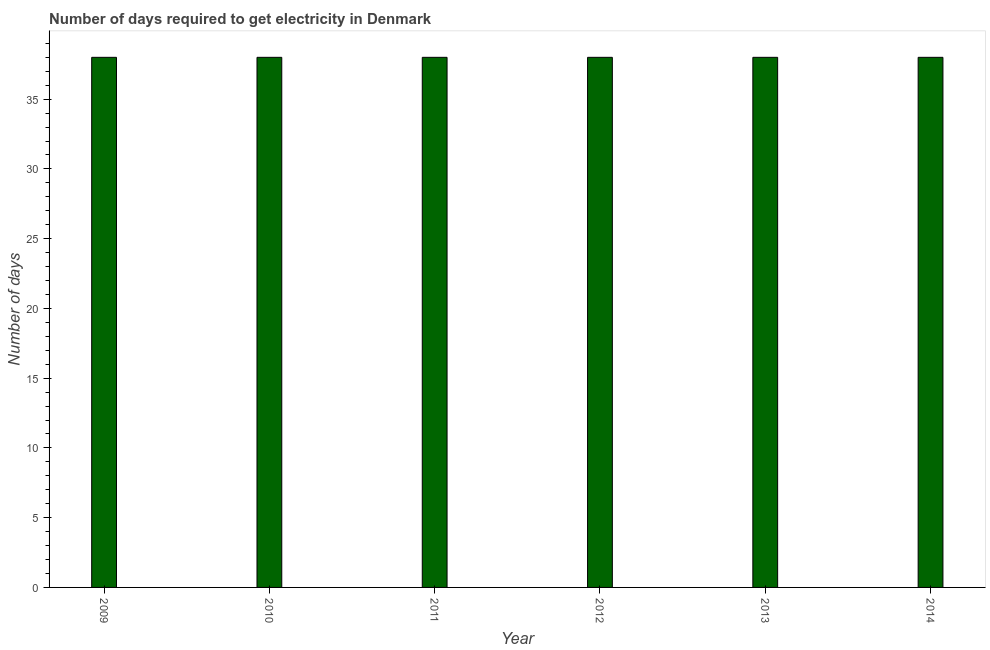Does the graph contain any zero values?
Your answer should be very brief. No. Does the graph contain grids?
Provide a succinct answer. No. What is the title of the graph?
Make the answer very short. Number of days required to get electricity in Denmark. What is the label or title of the X-axis?
Provide a succinct answer. Year. What is the label or title of the Y-axis?
Make the answer very short. Number of days. In which year was the time to get electricity maximum?
Make the answer very short. 2009. What is the sum of the time to get electricity?
Provide a succinct answer. 228. What is the difference between the time to get electricity in 2013 and 2014?
Your answer should be very brief. 0. What is the average time to get electricity per year?
Offer a terse response. 38. What is the median time to get electricity?
Give a very brief answer. 38. In how many years, is the time to get electricity greater than 9 ?
Your answer should be very brief. 6. Is the time to get electricity in 2010 less than that in 2012?
Make the answer very short. No. Is the sum of the time to get electricity in 2010 and 2011 greater than the maximum time to get electricity across all years?
Provide a short and direct response. Yes. Are all the bars in the graph horizontal?
Keep it short and to the point. No. How many years are there in the graph?
Your answer should be very brief. 6. What is the difference between two consecutive major ticks on the Y-axis?
Your answer should be very brief. 5. What is the Number of days of 2010?
Make the answer very short. 38. What is the Number of days in 2011?
Provide a succinct answer. 38. What is the Number of days of 2014?
Keep it short and to the point. 38. What is the difference between the Number of days in 2009 and 2010?
Your response must be concise. 0. What is the difference between the Number of days in 2009 and 2011?
Offer a very short reply. 0. What is the difference between the Number of days in 2009 and 2013?
Ensure brevity in your answer.  0. What is the difference between the Number of days in 2010 and 2011?
Offer a very short reply. 0. What is the difference between the Number of days in 2010 and 2013?
Offer a terse response. 0. What is the difference between the Number of days in 2011 and 2013?
Your response must be concise. 0. What is the difference between the Number of days in 2011 and 2014?
Offer a terse response. 0. What is the ratio of the Number of days in 2009 to that in 2012?
Make the answer very short. 1. What is the ratio of the Number of days in 2009 to that in 2013?
Provide a succinct answer. 1. What is the ratio of the Number of days in 2010 to that in 2012?
Provide a succinct answer. 1. What is the ratio of the Number of days in 2011 to that in 2012?
Offer a very short reply. 1. What is the ratio of the Number of days in 2011 to that in 2013?
Ensure brevity in your answer.  1. What is the ratio of the Number of days in 2011 to that in 2014?
Ensure brevity in your answer.  1. What is the ratio of the Number of days in 2012 to that in 2013?
Offer a very short reply. 1. 